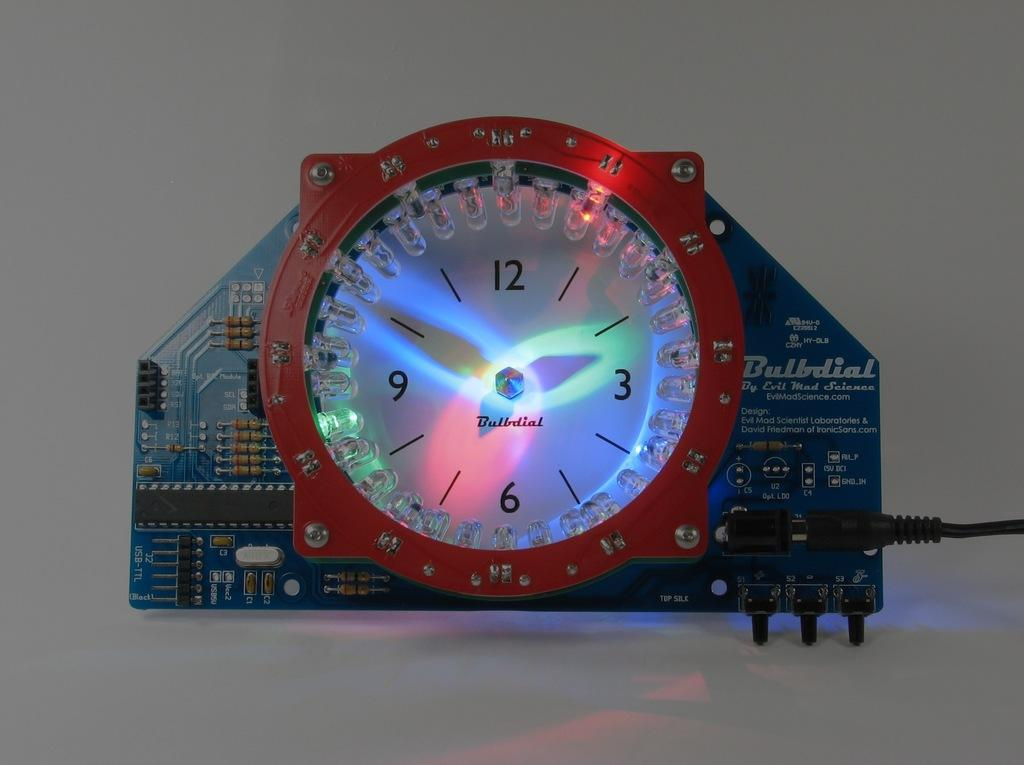<image>
Summarize the visual content of the image. A large clock with a circuit board fro the brand Bulldial. 